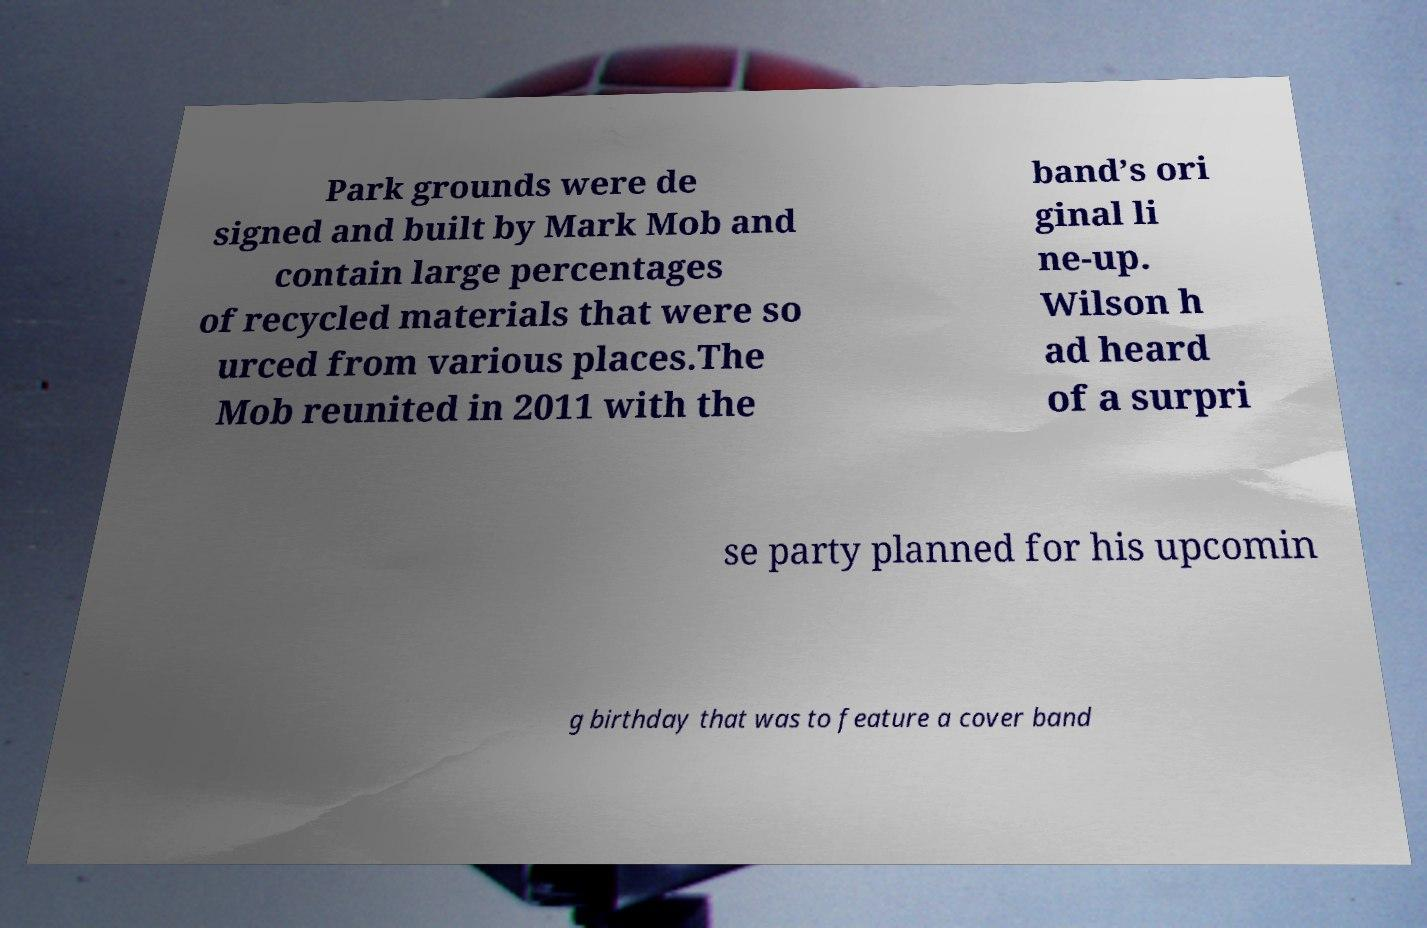Could you extract and type out the text from this image? Park grounds were de signed and built by Mark Mob and contain large percentages of recycled materials that were so urced from various places.The Mob reunited in 2011 with the band’s ori ginal li ne-up. Wilson h ad heard of a surpri se party planned for his upcomin g birthday that was to feature a cover band 